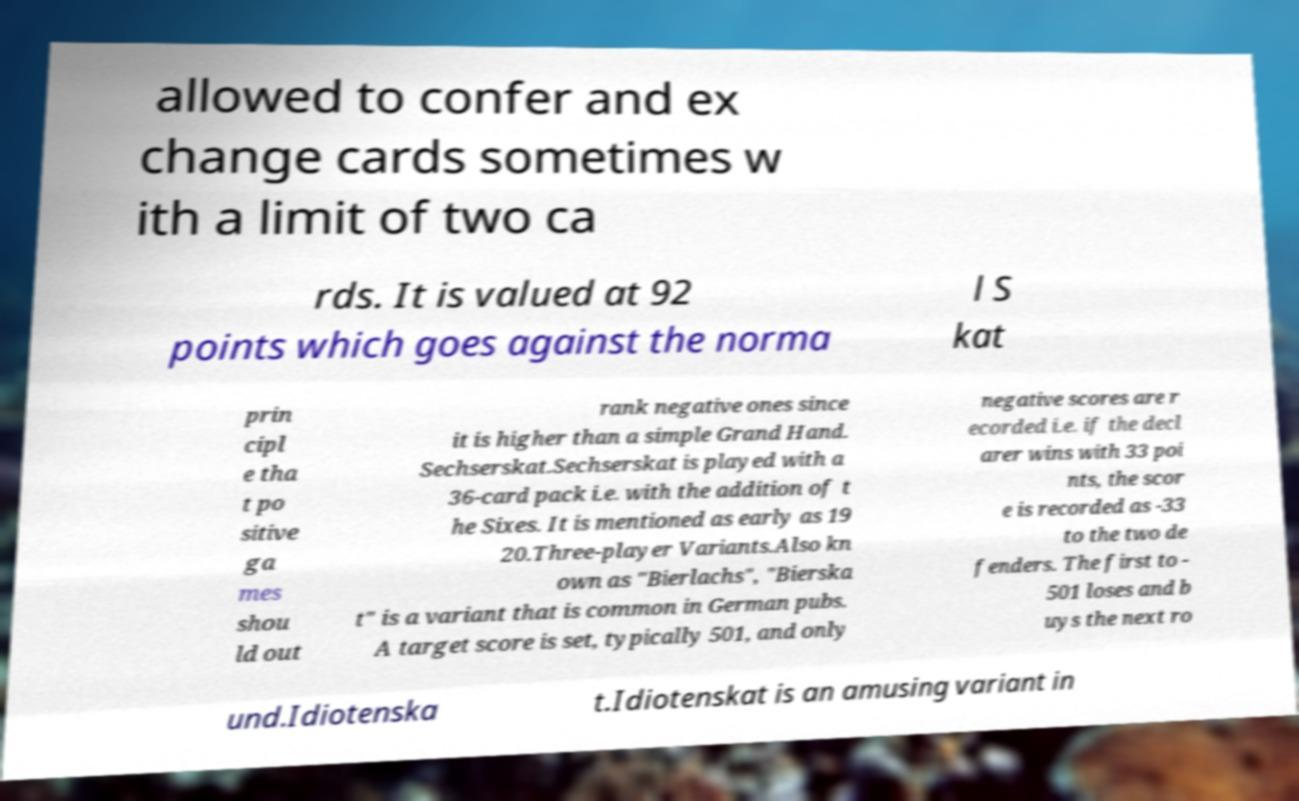What messages or text are displayed in this image? I need them in a readable, typed format. allowed to confer and ex change cards sometimes w ith a limit of two ca rds. It is valued at 92 points which goes against the norma l S kat prin cipl e tha t po sitive ga mes shou ld out rank negative ones since it is higher than a simple Grand Hand. Sechserskat.Sechserskat is played with a 36-card pack i.e. with the addition of t he Sixes. It is mentioned as early as 19 20.Three-player Variants.Also kn own as "Bierlachs", "Bierska t" is a variant that is common in German pubs. A target score is set, typically 501, and only negative scores are r ecorded i.e. if the decl arer wins with 33 poi nts, the scor e is recorded as -33 to the two de fenders. The first to - 501 loses and b uys the next ro und.Idiotenska t.Idiotenskat is an amusing variant in 